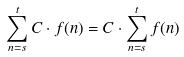Convert formula to latex. <formula><loc_0><loc_0><loc_500><loc_500>\sum _ { n = s } ^ { t } C \cdot f ( n ) = C \cdot \sum _ { n = s } ^ { t } f ( n )</formula> 